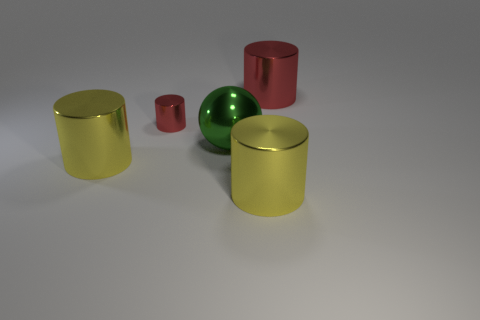Subtract all gray cylinders. Subtract all purple blocks. How many cylinders are left? 4 Add 3 shiny spheres. How many objects exist? 8 Subtract all cylinders. How many objects are left? 1 Add 3 large red cylinders. How many large red cylinders exist? 4 Subtract 0 cyan spheres. How many objects are left? 5 Subtract all tiny red shiny cylinders. Subtract all yellow objects. How many objects are left? 2 Add 1 metallic cylinders. How many metallic cylinders are left? 5 